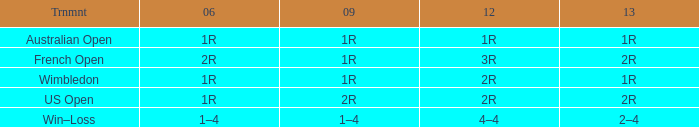What shows for 2013 when the 2012 is 2r, and a 2009 is 2r? 2R. 